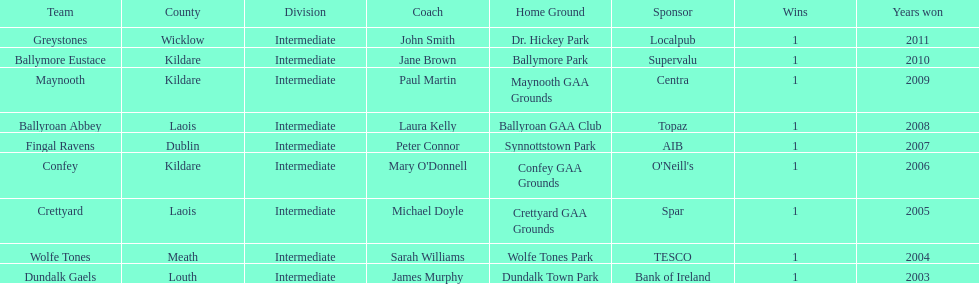What is the total of wins on the chart 9. 